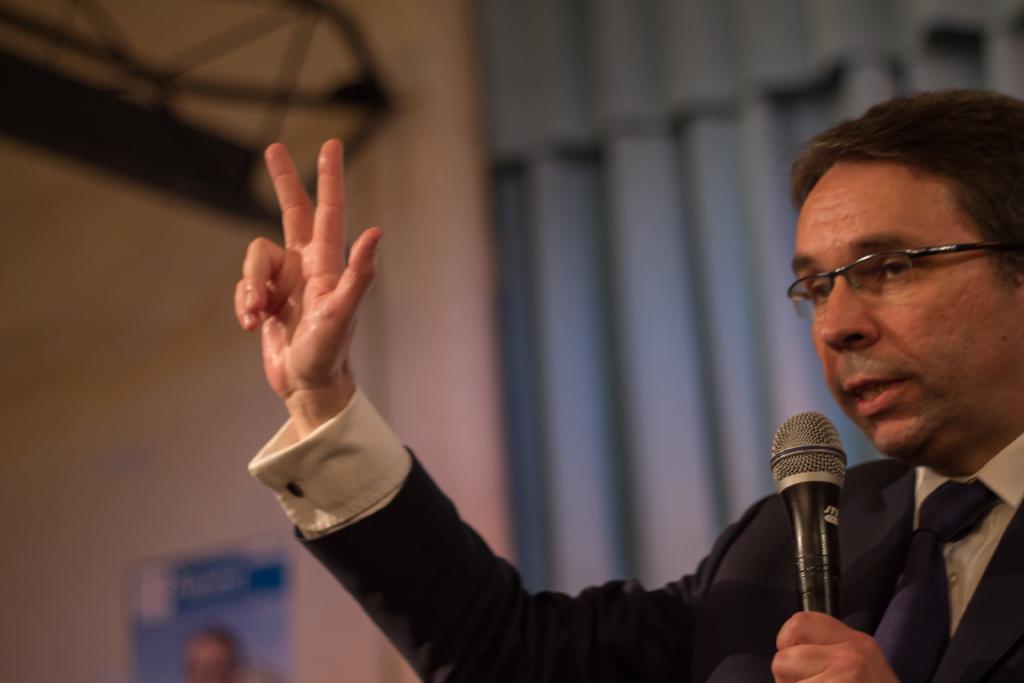In one or two sentences, can you explain what this image depicts? This picture is taken inside a room. In the right side one person is talking something. He is holding a mic. He is wearing glasses,suit,white shirt,blue tie. In the background there is curtain,wall,poster. 